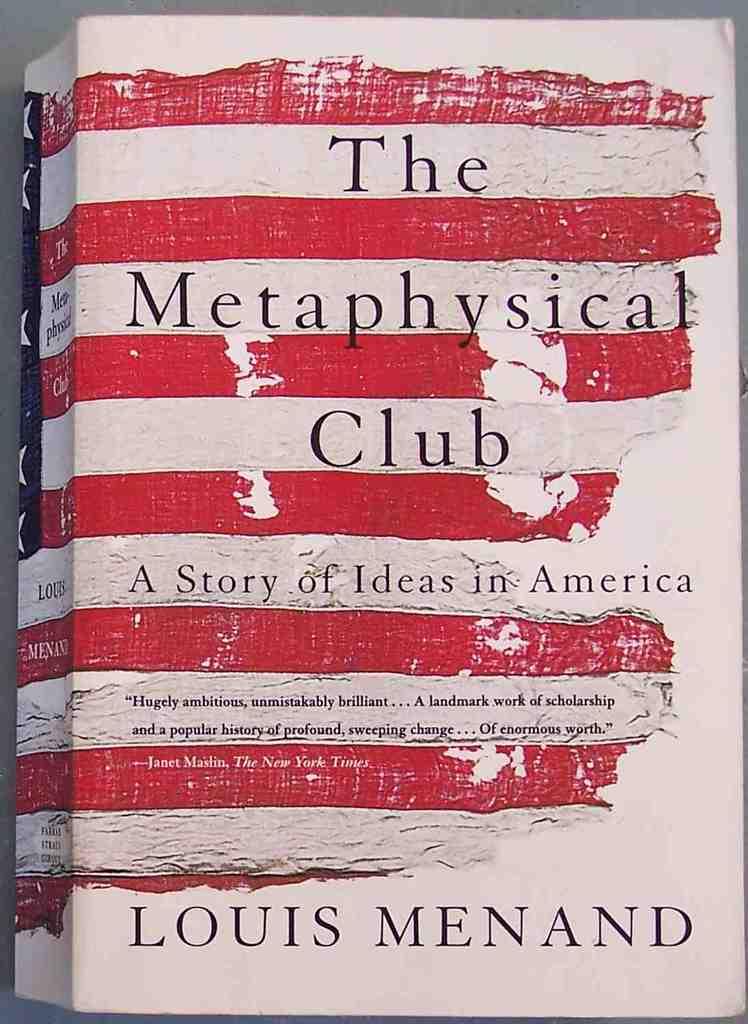What is the name of the book?
Provide a short and direct response. The metaphysical club. Who is the author of the book?
Provide a succinct answer. Louis menand. 